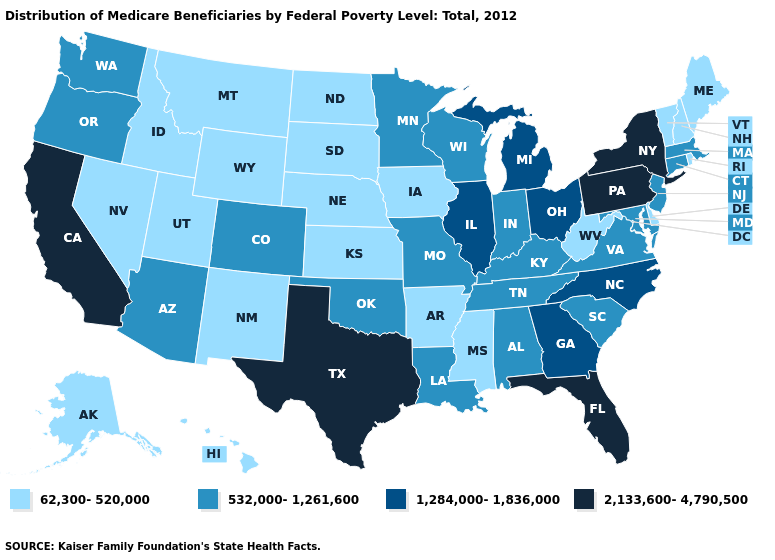What is the lowest value in states that border Arkansas?
Give a very brief answer. 62,300-520,000. What is the lowest value in states that border Idaho?
Be succinct. 62,300-520,000. What is the lowest value in the MidWest?
Give a very brief answer. 62,300-520,000. Which states hav the highest value in the MidWest?
Concise answer only. Illinois, Michigan, Ohio. Name the states that have a value in the range 1,284,000-1,836,000?
Quick response, please. Georgia, Illinois, Michigan, North Carolina, Ohio. What is the highest value in states that border Arizona?
Short answer required. 2,133,600-4,790,500. Does the map have missing data?
Short answer required. No. Does the map have missing data?
Be succinct. No. Name the states that have a value in the range 1,284,000-1,836,000?
Short answer required. Georgia, Illinois, Michigan, North Carolina, Ohio. What is the value of Texas?
Keep it brief. 2,133,600-4,790,500. Does Texas have the highest value in the South?
Short answer required. Yes. Name the states that have a value in the range 2,133,600-4,790,500?
Concise answer only. California, Florida, New York, Pennsylvania, Texas. Name the states that have a value in the range 1,284,000-1,836,000?
Concise answer only. Georgia, Illinois, Michigan, North Carolina, Ohio. Name the states that have a value in the range 62,300-520,000?
Concise answer only. Alaska, Arkansas, Delaware, Hawaii, Idaho, Iowa, Kansas, Maine, Mississippi, Montana, Nebraska, Nevada, New Hampshire, New Mexico, North Dakota, Rhode Island, South Dakota, Utah, Vermont, West Virginia, Wyoming. Does Wisconsin have the lowest value in the USA?
Keep it brief. No. 